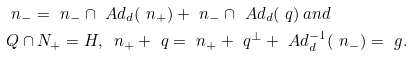<formula> <loc_0><loc_0><loc_500><loc_500>& \ n _ { - } = \ n _ { - } \cap \ A d _ { d } ( \ n _ { + } ) + \ n _ { - } \cap \ A d _ { d } ( \ q ) \, a n d \\ & Q \cap N _ { + } = H , \, \ n _ { + } + \ q = \ n _ { + } + \ q ^ { \perp } + \ A d _ { d } ^ { - 1 } ( \ n _ { - } ) = \ g .</formula> 